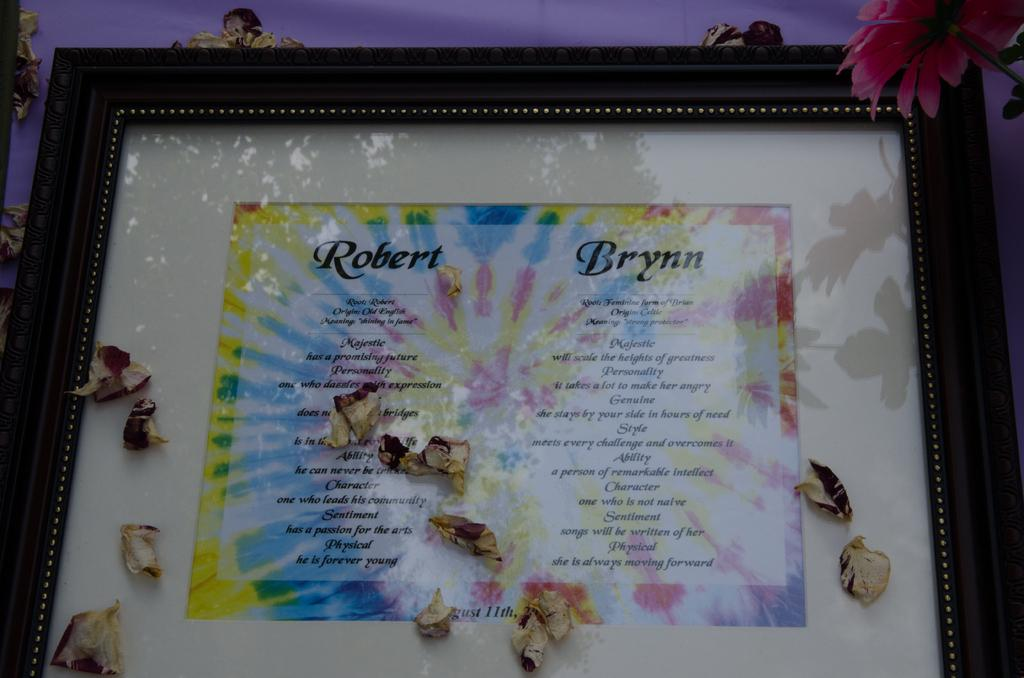What is for Facts: What is the main subject of the image? The main subject of the image is a photo frame. What can be seen on the photo frame? There is matter written on the photo frame. Can you see the coast in the image? No, there is no coast visible in the image; it is a close view of a photo frame. What type of arm is depicted on the photo frame? There is no arm depicted on the photo frame; the image only shows the frame itself and the matter written on it. 